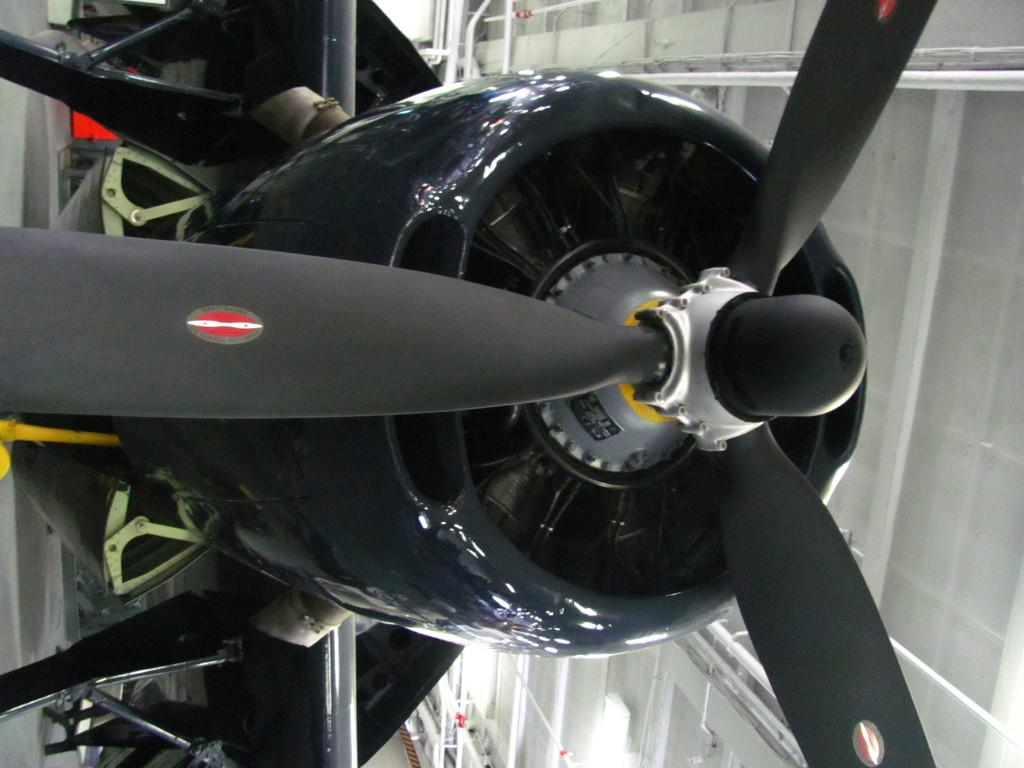What type of engine is in the image? There is a propeller engine in the image. Can you describe anything visible in the background of the image? Unfortunately, the provided facts do not give any specific details about the objects visible in the background of the image. Is there a veil covering the propeller engine in the image? No, there is no veil covering the propeller engine in the image. Can you see a giraffe in the image? No, there is no giraffe present in the image. 